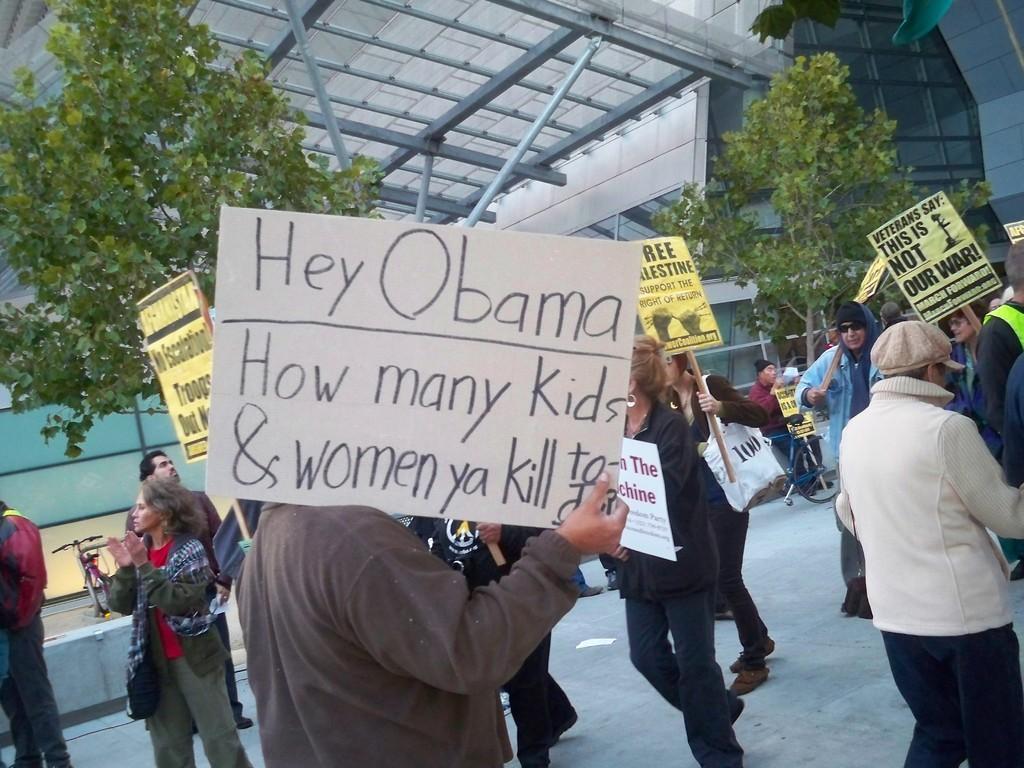Could you give a brief overview of what you see in this image? In this picture there is a man who is wearing grey jacket and he is holding a poster. Beside him we can see a woman who is wearing black dress and she is also holding the poster. On the right we can see the group of persons were standing on the road. Beside them there is a man who is standing near to the bicycle. On the left there is a bicycle near the tree. In the background we can see the building. 